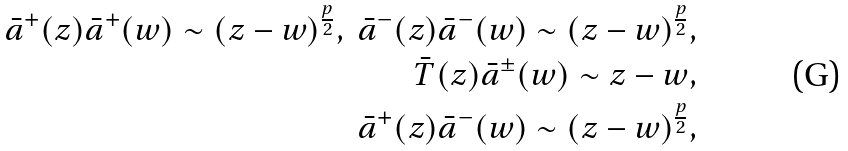Convert formula to latex. <formula><loc_0><loc_0><loc_500><loc_500>\bar { a } ^ { + } ( z ) \bar { a } ^ { + } ( w ) \sim ( z - w ) ^ { \frac { p } { 2 } } , \ \bar { a } ^ { - } ( z ) \bar { a } ^ { - } ( w ) \sim ( z - w ) ^ { \frac { p } { 2 } } , \\ \bar { T } ( z ) \bar { a } ^ { \pm } ( w ) \sim z - w , \\ \bar { a } ^ { + } ( z ) \bar { a } ^ { - } ( w ) \sim ( z - w ) ^ { \frac { p } { 2 } } ,</formula> 